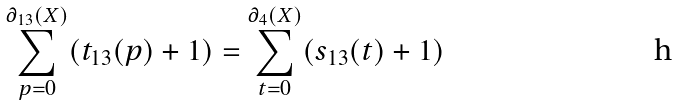<formula> <loc_0><loc_0><loc_500><loc_500>\sum _ { p = 0 } ^ { \partial _ { 1 3 } ( X ) } ( t _ { 1 3 } ( p ) + 1 ) = \sum _ { t = 0 } ^ { \partial _ { 4 } ( X ) } ( s _ { 1 3 } ( t ) + 1 )</formula> 